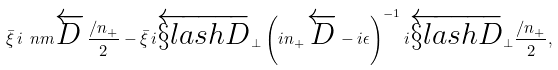<formula> <loc_0><loc_0><loc_500><loc_500>\bar { \xi } \, i \ n m \overleftarrow { D } \, \frac { \slash n _ { + } } { 2 } - \bar { \xi } \, i \overleftarrow { \S l a s h { D } } _ { \perp } \left ( i n _ { + } \, \overleftarrow { D } - i \epsilon \right ) ^ { - 1 } i \overleftarrow { \S l a s h { D } } _ { \perp } \frac { \slash n _ { + } } { 2 } ,</formula> 